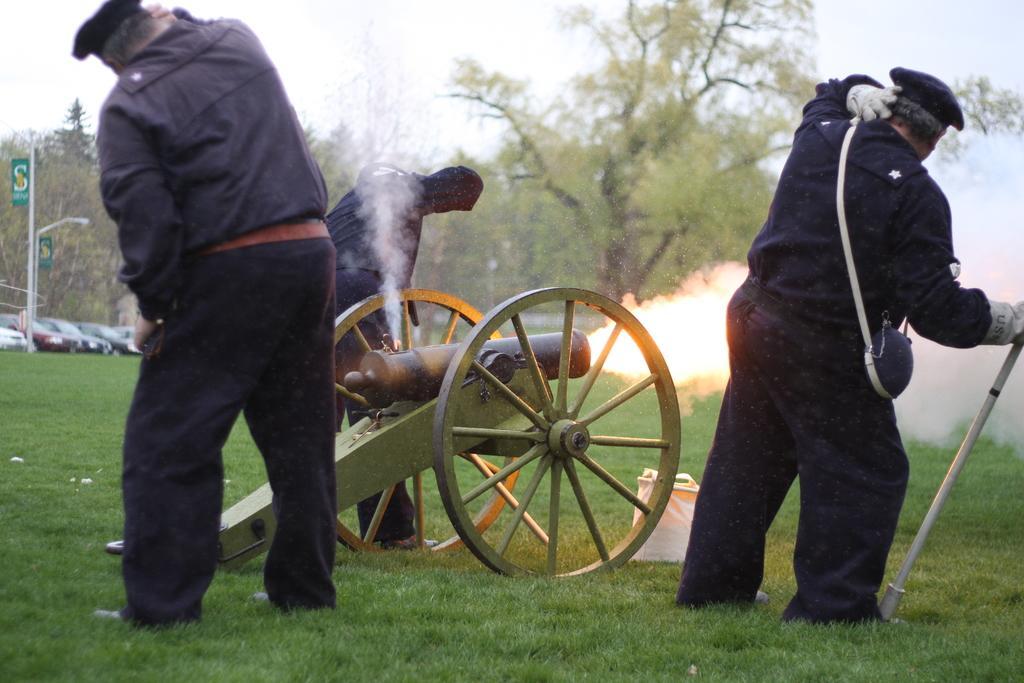In one or two sentences, can you explain what this image depicts? This picture contains a cannon. We see three men in black uniform are standing beside the cannon. Beside that, we see a white color bag. At the bottom of the picture, we see grass. In the background, we see poles and cars parked on the road. There are trees in the background. 